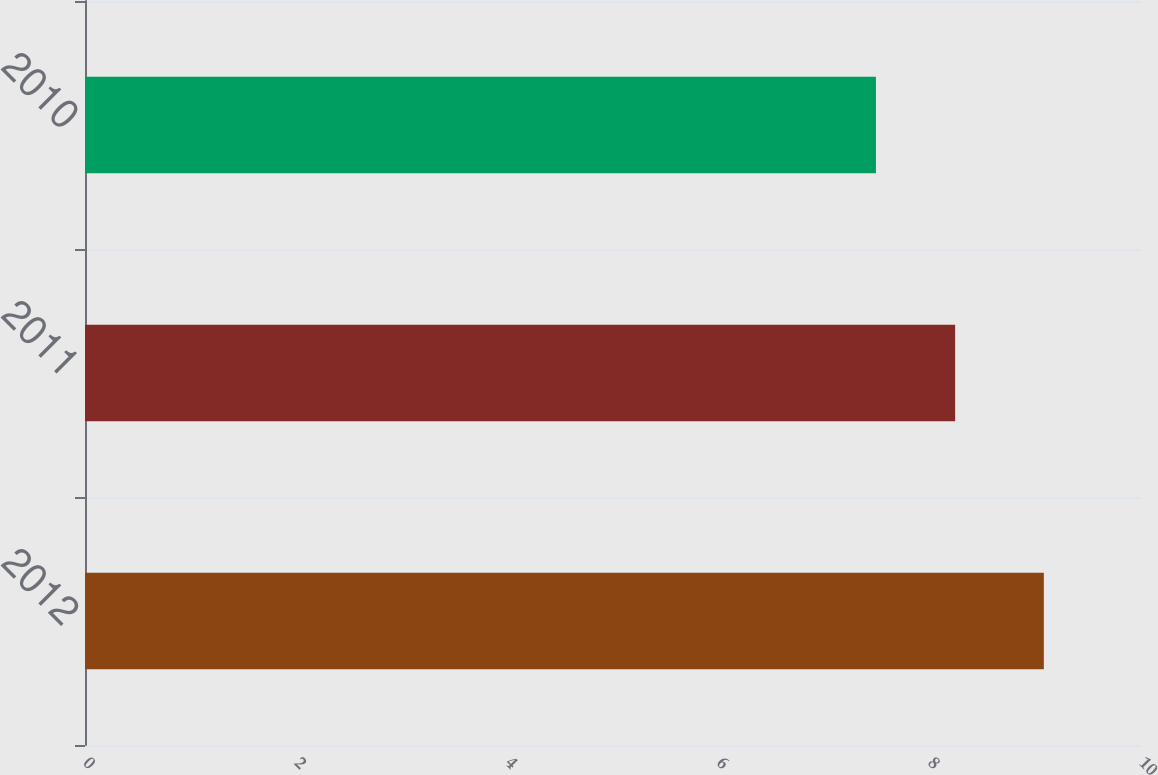Convert chart to OTSL. <chart><loc_0><loc_0><loc_500><loc_500><bar_chart><fcel>2012<fcel>2011<fcel>2010<nl><fcel>9.08<fcel>8.24<fcel>7.49<nl></chart> 